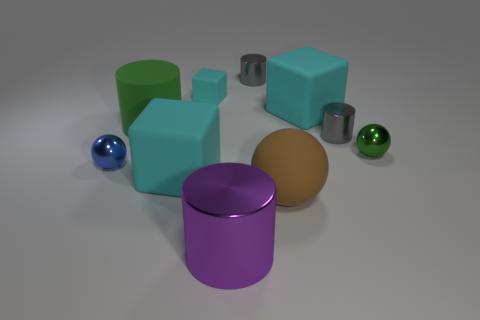There is a ball that is behind the brown thing and left of the tiny green shiny thing; what size is it?
Make the answer very short. Small. What shape is the tiny green thing?
Keep it short and to the point. Sphere. Is there a large matte block behind the tiny sphere to the right of the large shiny cylinder?
Make the answer very short. Yes. What is the material of the green object that is the same size as the purple metallic cylinder?
Offer a terse response. Rubber. Is there a blue metallic ball that has the same size as the blue metallic thing?
Offer a terse response. No. What is the material of the small gray cylinder behind the matte cylinder?
Your answer should be very brief. Metal. Is the material of the gray cylinder that is in front of the tiny cyan cube the same as the small cyan object?
Provide a short and direct response. No. What is the shape of the purple object that is the same size as the green matte cylinder?
Provide a succinct answer. Cylinder. How many tiny balls have the same color as the large rubber cylinder?
Your answer should be very brief. 1. Is the number of metallic spheres left of the green metal ball less than the number of cyan things left of the rubber sphere?
Offer a terse response. Yes. 